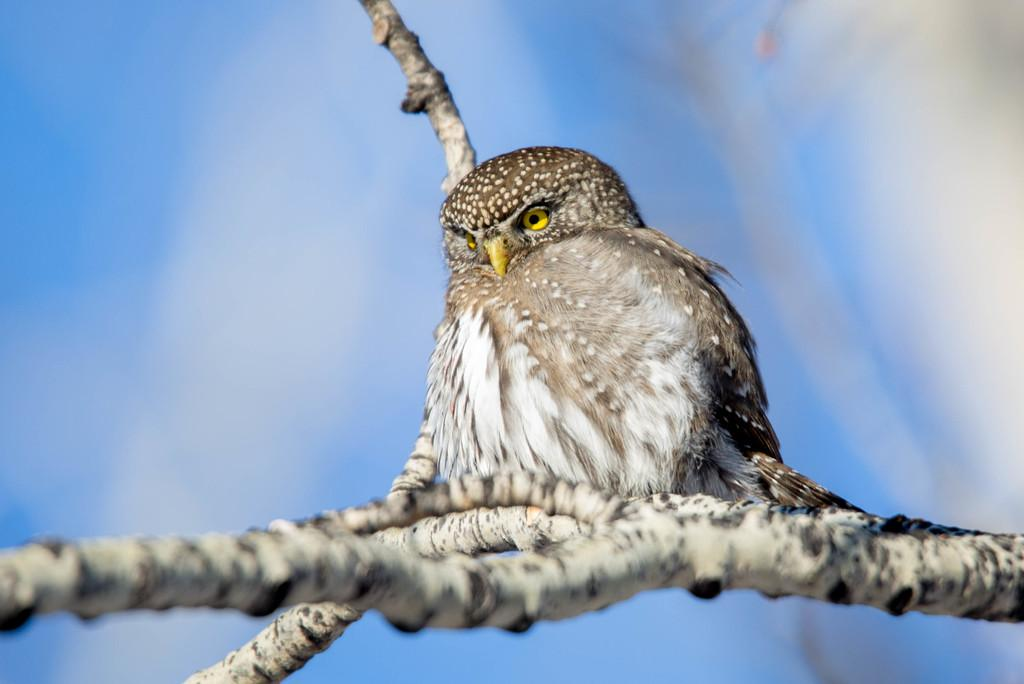What animal is the main subject of the image? There is an owl in the image. Where is the owl located in the image? The owl is on a stem. What can be seen in the background of the image? The sky is visible in the background of the image. How many women are present in the image? There are no women present in the image; it features an owl on a stem with a visible sky background. 